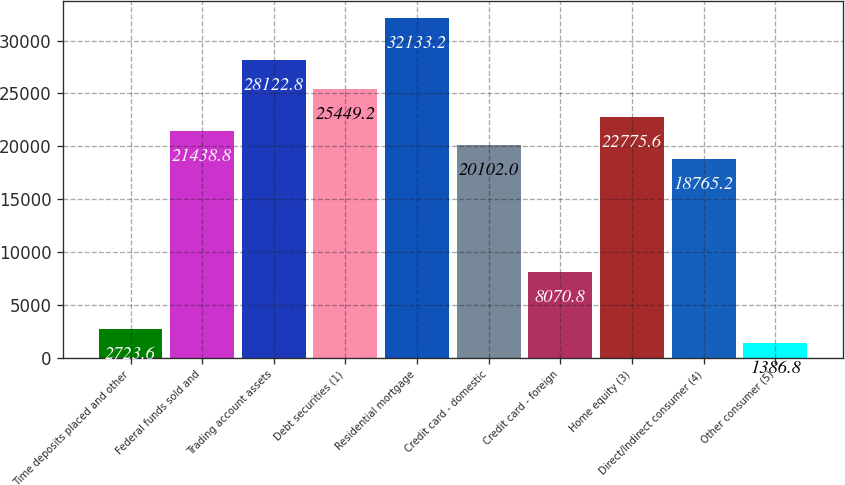Convert chart. <chart><loc_0><loc_0><loc_500><loc_500><bar_chart><fcel>Time deposits placed and other<fcel>Federal funds sold and<fcel>Trading account assets<fcel>Debt securities (1)<fcel>Residential mortgage<fcel>Credit card - domestic<fcel>Credit card - foreign<fcel>Home equity (3)<fcel>Direct/Indirect consumer (4)<fcel>Other consumer (5)<nl><fcel>2723.6<fcel>21438.8<fcel>28122.8<fcel>25449.2<fcel>32133.2<fcel>20102<fcel>8070.8<fcel>22775.6<fcel>18765.2<fcel>1386.8<nl></chart> 